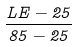<formula> <loc_0><loc_0><loc_500><loc_500>\frac { L E - 2 5 } { 8 5 - 2 5 }</formula> 